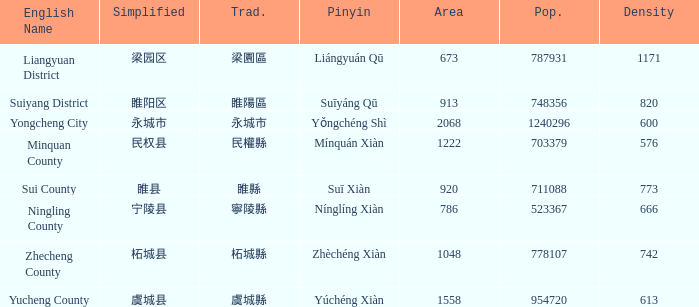How many figures are there for density for Yucheng County? 1.0. 